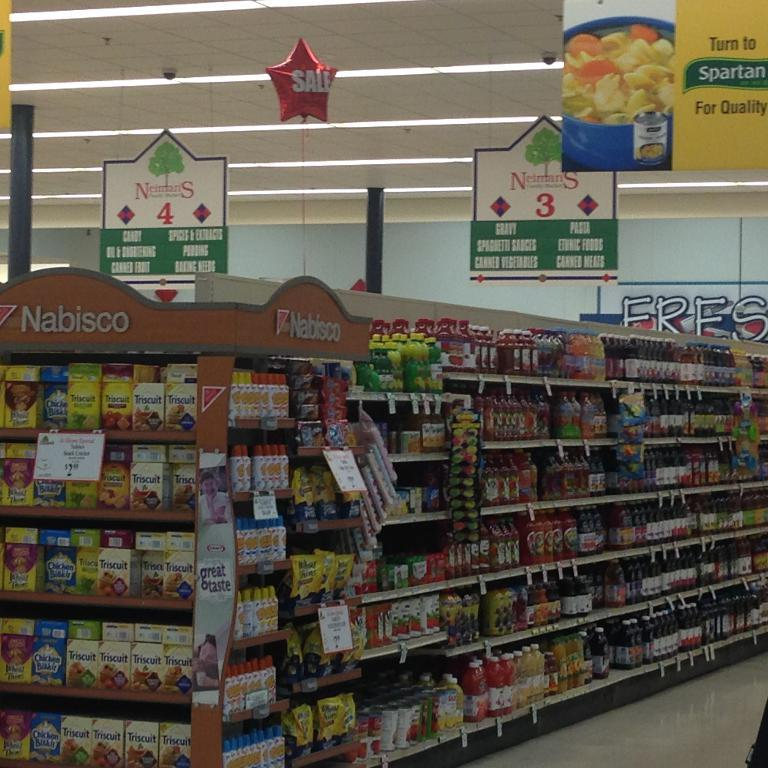What type of establishment is shown in the picture? There is a supermarket in the picture. What can be found inside the supermarket? The supermarket has groceries. How is the supermarket illuminated? There are lights in the supermarket. Are there any additional features on the ceiling of the supermarket? Yes, there are boards attached to the ceiling in the supermarket. What type of book is being read by the customer in the supermarket? There is no customer reading a book in the supermarket; the image only shows the supermarket itself and its features. 